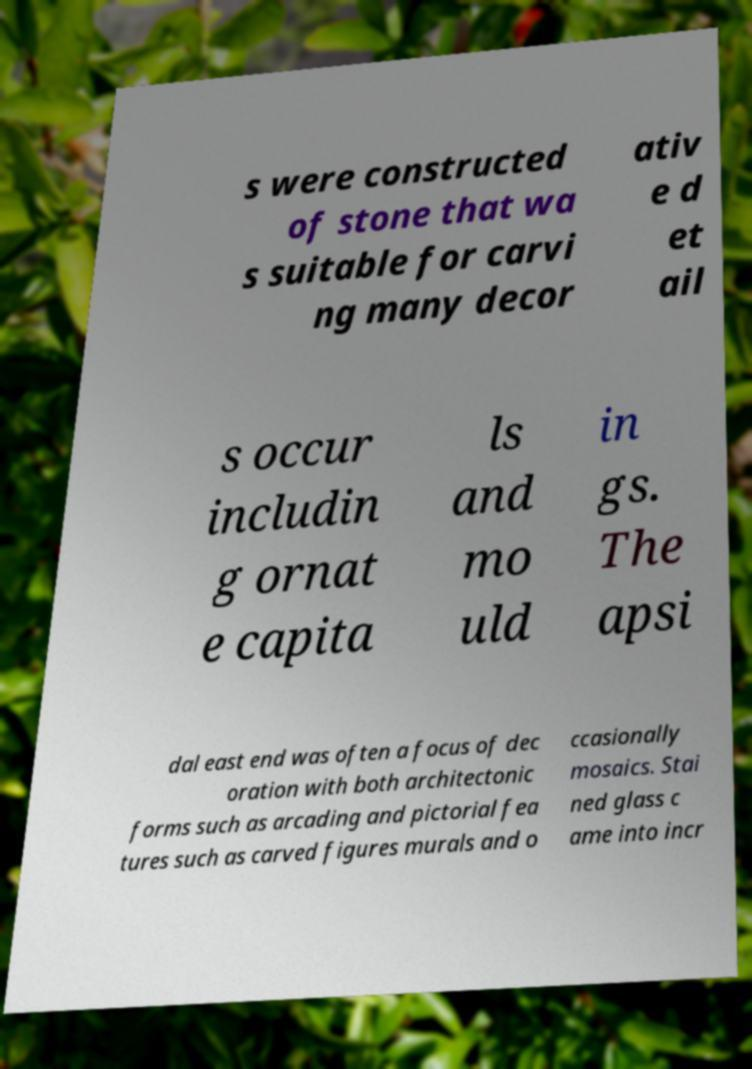Please read and relay the text visible in this image. What does it say? s were constructed of stone that wa s suitable for carvi ng many decor ativ e d et ail s occur includin g ornat e capita ls and mo uld in gs. The apsi dal east end was often a focus of dec oration with both architectonic forms such as arcading and pictorial fea tures such as carved figures murals and o ccasionally mosaics. Stai ned glass c ame into incr 